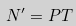Convert formula to latex. <formula><loc_0><loc_0><loc_500><loc_500>N ^ { \prime } = P T</formula> 